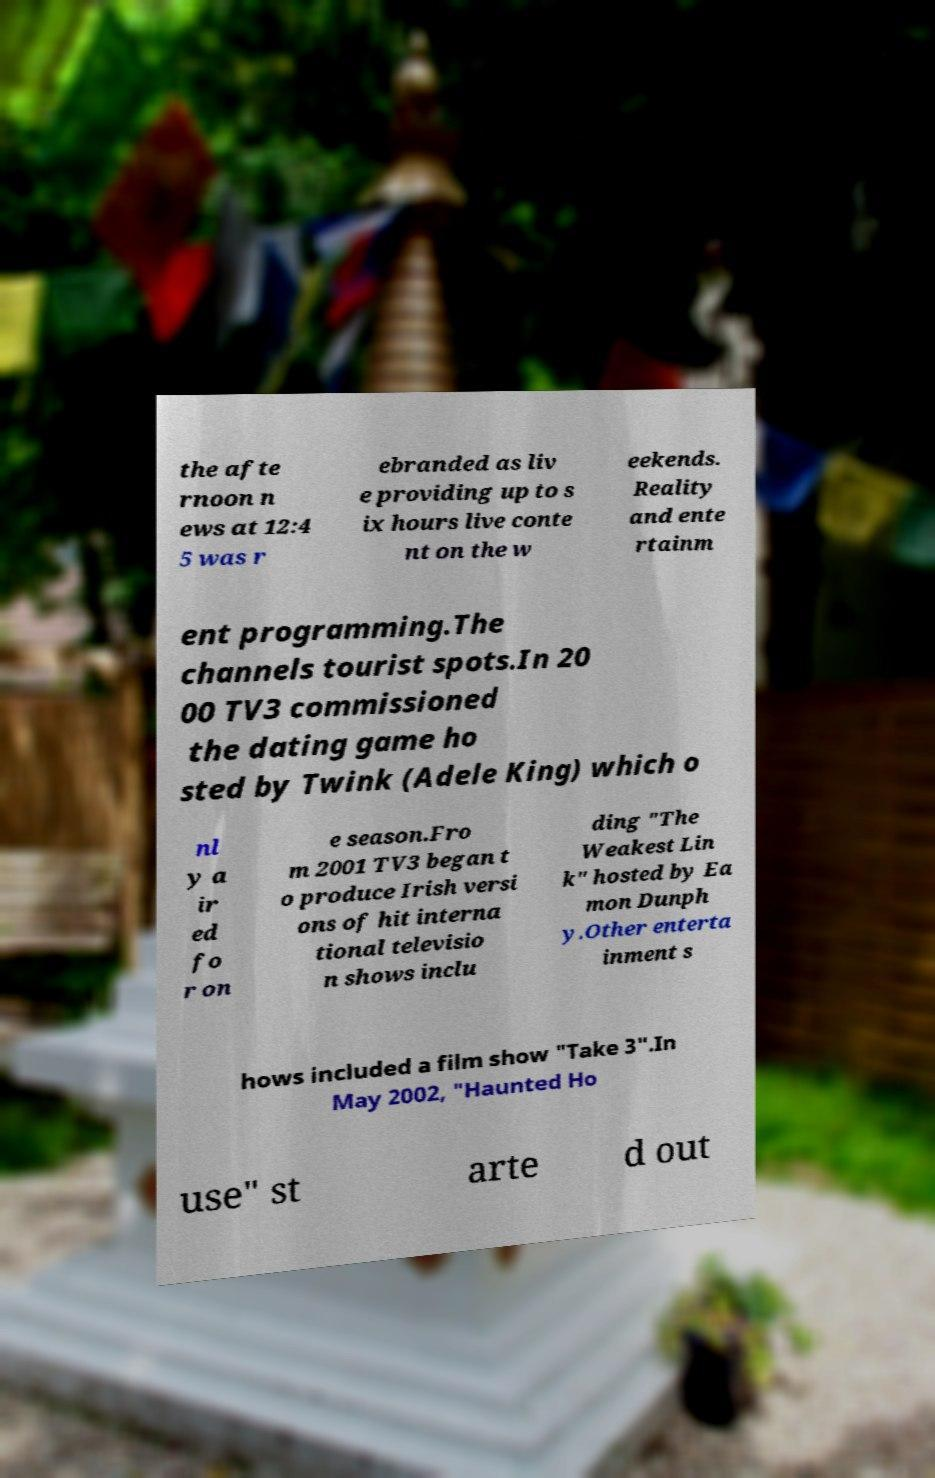Can you read and provide the text displayed in the image?This photo seems to have some interesting text. Can you extract and type it out for me? the afte rnoon n ews at 12:4 5 was r ebranded as liv e providing up to s ix hours live conte nt on the w eekends. Reality and ente rtainm ent programming.The channels tourist spots.In 20 00 TV3 commissioned the dating game ho sted by Twink (Adele King) which o nl y a ir ed fo r on e season.Fro m 2001 TV3 began t o produce Irish versi ons of hit interna tional televisio n shows inclu ding "The Weakest Lin k" hosted by Ea mon Dunph y.Other enterta inment s hows included a film show "Take 3".In May 2002, "Haunted Ho use" st arte d out 